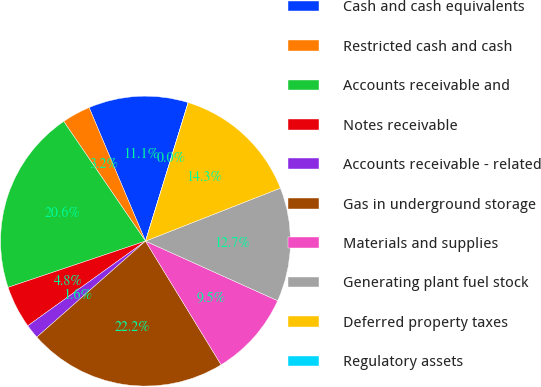Convert chart. <chart><loc_0><loc_0><loc_500><loc_500><pie_chart><fcel>Cash and cash equivalents<fcel>Restricted cash and cash<fcel>Accounts receivable and<fcel>Notes receivable<fcel>Accounts receivable - related<fcel>Gas in underground storage<fcel>Materials and supplies<fcel>Generating plant fuel stock<fcel>Deferred property taxes<fcel>Regulatory assets<nl><fcel>11.11%<fcel>3.18%<fcel>20.63%<fcel>4.76%<fcel>1.59%<fcel>22.22%<fcel>9.52%<fcel>12.7%<fcel>14.29%<fcel>0.0%<nl></chart> 